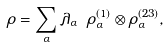<formula> <loc_0><loc_0><loc_500><loc_500>\rho = \sum _ { \alpha } \lambda _ { \alpha } \ \rho ^ { ( 1 ) } _ { \alpha } \otimes \rho ^ { ( 2 3 ) } _ { \alpha } ,</formula> 